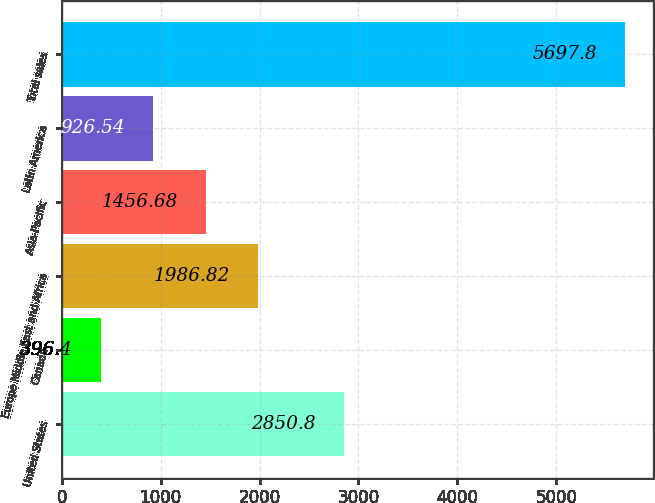<chart> <loc_0><loc_0><loc_500><loc_500><bar_chart><fcel>United States<fcel>Canada<fcel>Europe Middle East and Africa<fcel>Asia-Pacific<fcel>Latin America<fcel>Total sales<nl><fcel>2850.8<fcel>396.4<fcel>1986.82<fcel>1456.68<fcel>926.54<fcel>5697.8<nl></chart> 